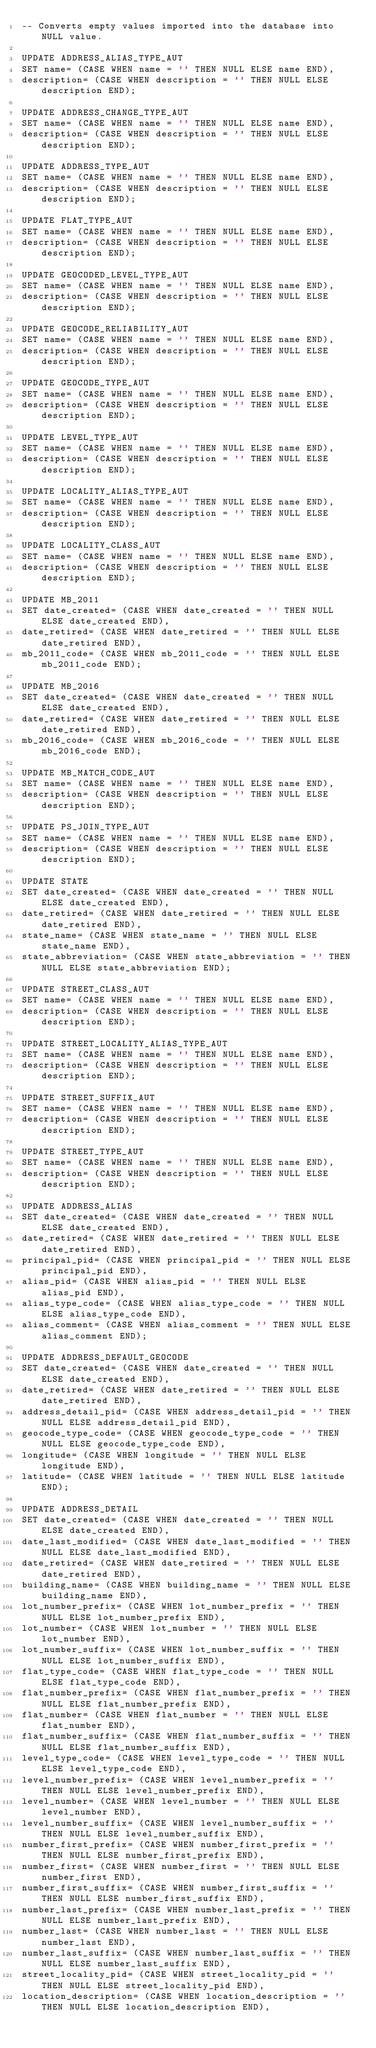<code> <loc_0><loc_0><loc_500><loc_500><_SQL_>-- Converts empty values imported into the database into NULL value.

UPDATE ADDRESS_ALIAS_TYPE_AUT
SET name= (CASE WHEN name = '' THEN NULL ELSE name END),
description= (CASE WHEN description = '' THEN NULL ELSE description END);

UPDATE ADDRESS_CHANGE_TYPE_AUT
SET name= (CASE WHEN name = '' THEN NULL ELSE name END),
description= (CASE WHEN description = '' THEN NULL ELSE description END);

UPDATE ADDRESS_TYPE_AUT
SET name= (CASE WHEN name = '' THEN NULL ELSE name END),
description= (CASE WHEN description = '' THEN NULL ELSE description END);

UPDATE FLAT_TYPE_AUT
SET name= (CASE WHEN name = '' THEN NULL ELSE name END),
description= (CASE WHEN description = '' THEN NULL ELSE description END);

UPDATE GEOCODED_LEVEL_TYPE_AUT
SET name= (CASE WHEN name = '' THEN NULL ELSE name END),
description= (CASE WHEN description = '' THEN NULL ELSE description END);

UPDATE GEOCODE_RELIABILITY_AUT
SET name= (CASE WHEN name = '' THEN NULL ELSE name END),
description= (CASE WHEN description = '' THEN NULL ELSE description END);

UPDATE GEOCODE_TYPE_AUT
SET name= (CASE WHEN name = '' THEN NULL ELSE name END),
description= (CASE WHEN description = '' THEN NULL ELSE description END);

UPDATE LEVEL_TYPE_AUT
SET name= (CASE WHEN name = '' THEN NULL ELSE name END),
description= (CASE WHEN description = '' THEN NULL ELSE description END);

UPDATE LOCALITY_ALIAS_TYPE_AUT
SET name= (CASE WHEN name = '' THEN NULL ELSE name END),
description= (CASE WHEN description = '' THEN NULL ELSE description END);

UPDATE LOCALITY_CLASS_AUT
SET name= (CASE WHEN name = '' THEN NULL ELSE name END),
description= (CASE WHEN description = '' THEN NULL ELSE description END);

UPDATE MB_2011
SET date_created= (CASE WHEN date_created = '' THEN NULL ELSE date_created END),
date_retired= (CASE WHEN date_retired = '' THEN NULL ELSE date_retired END),
mb_2011_code= (CASE WHEN mb_2011_code = '' THEN NULL ELSE mb_2011_code END);

UPDATE MB_2016
SET date_created= (CASE WHEN date_created = '' THEN NULL ELSE date_created END),
date_retired= (CASE WHEN date_retired = '' THEN NULL ELSE date_retired END),
mb_2016_code= (CASE WHEN mb_2016_code = '' THEN NULL ELSE mb_2016_code END);

UPDATE MB_MATCH_CODE_AUT
SET name= (CASE WHEN name = '' THEN NULL ELSE name END),
description= (CASE WHEN description = '' THEN NULL ELSE description END);

UPDATE PS_JOIN_TYPE_AUT
SET name= (CASE WHEN name = '' THEN NULL ELSE name END),
description= (CASE WHEN description = '' THEN NULL ELSE description END);

UPDATE STATE
SET date_created= (CASE WHEN date_created = '' THEN NULL ELSE date_created END),
date_retired= (CASE WHEN date_retired = '' THEN NULL ELSE date_retired END),
state_name= (CASE WHEN state_name = '' THEN NULL ELSE state_name END),
state_abbreviation= (CASE WHEN state_abbreviation = '' THEN NULL ELSE state_abbreviation END);

UPDATE STREET_CLASS_AUT
SET name= (CASE WHEN name = '' THEN NULL ELSE name END),
description= (CASE WHEN description = '' THEN NULL ELSE description END);

UPDATE STREET_LOCALITY_ALIAS_TYPE_AUT
SET name= (CASE WHEN name = '' THEN NULL ELSE name END),
description= (CASE WHEN description = '' THEN NULL ELSE description END);

UPDATE STREET_SUFFIX_AUT
SET name= (CASE WHEN name = '' THEN NULL ELSE name END),
description= (CASE WHEN description = '' THEN NULL ELSE description END);

UPDATE STREET_TYPE_AUT
SET name= (CASE WHEN name = '' THEN NULL ELSE name END),
description= (CASE WHEN description = '' THEN NULL ELSE description END);

UPDATE ADDRESS_ALIAS
SET date_created= (CASE WHEN date_created = '' THEN NULL ELSE date_created END),
date_retired= (CASE WHEN date_retired = '' THEN NULL ELSE date_retired END),
principal_pid= (CASE WHEN principal_pid = '' THEN NULL ELSE principal_pid END),
alias_pid= (CASE WHEN alias_pid = '' THEN NULL ELSE alias_pid END),
alias_type_code= (CASE WHEN alias_type_code = '' THEN NULL ELSE alias_type_code END),
alias_comment= (CASE WHEN alias_comment = '' THEN NULL ELSE alias_comment END);

UPDATE ADDRESS_DEFAULT_GEOCODE
SET date_created= (CASE WHEN date_created = '' THEN NULL ELSE date_created END),
date_retired= (CASE WHEN date_retired = '' THEN NULL ELSE date_retired END),
address_detail_pid= (CASE WHEN address_detail_pid = '' THEN NULL ELSE address_detail_pid END),
geocode_type_code= (CASE WHEN geocode_type_code = '' THEN NULL ELSE geocode_type_code END),
longitude= (CASE WHEN longitude = '' THEN NULL ELSE longitude END),
latitude= (CASE WHEN latitude = '' THEN NULL ELSE latitude END);

UPDATE ADDRESS_DETAIL
SET date_created= (CASE WHEN date_created = '' THEN NULL ELSE date_created END),
date_last_modified= (CASE WHEN date_last_modified = '' THEN NULL ELSE date_last_modified END),
date_retired= (CASE WHEN date_retired = '' THEN NULL ELSE date_retired END),
building_name= (CASE WHEN building_name = '' THEN NULL ELSE building_name END),
lot_number_prefix= (CASE WHEN lot_number_prefix = '' THEN NULL ELSE lot_number_prefix END),
lot_number= (CASE WHEN lot_number = '' THEN NULL ELSE lot_number END),
lot_number_suffix= (CASE WHEN lot_number_suffix = '' THEN NULL ELSE lot_number_suffix END),
flat_type_code= (CASE WHEN flat_type_code = '' THEN NULL ELSE flat_type_code END),
flat_number_prefix= (CASE WHEN flat_number_prefix = '' THEN NULL ELSE flat_number_prefix END),
flat_number= (CASE WHEN flat_number = '' THEN NULL ELSE flat_number END),
flat_number_suffix= (CASE WHEN flat_number_suffix = '' THEN NULL ELSE flat_number_suffix END),
level_type_code= (CASE WHEN level_type_code = '' THEN NULL ELSE level_type_code END),
level_number_prefix= (CASE WHEN level_number_prefix = '' THEN NULL ELSE level_number_prefix END),
level_number= (CASE WHEN level_number = '' THEN NULL ELSE level_number END),
level_number_suffix= (CASE WHEN level_number_suffix = '' THEN NULL ELSE level_number_suffix END),
number_first_prefix= (CASE WHEN number_first_prefix = '' THEN NULL ELSE number_first_prefix END),
number_first= (CASE WHEN number_first = '' THEN NULL ELSE number_first END),
number_first_suffix= (CASE WHEN number_first_suffix = '' THEN NULL ELSE number_first_suffix END),
number_last_prefix= (CASE WHEN number_last_prefix = '' THEN NULL ELSE number_last_prefix END),
number_last= (CASE WHEN number_last = '' THEN NULL ELSE number_last END),
number_last_suffix= (CASE WHEN number_last_suffix = '' THEN NULL ELSE number_last_suffix END),
street_locality_pid= (CASE WHEN street_locality_pid = '' THEN NULL ELSE street_locality_pid END),
location_description= (CASE WHEN location_description = '' THEN NULL ELSE location_description END),</code> 